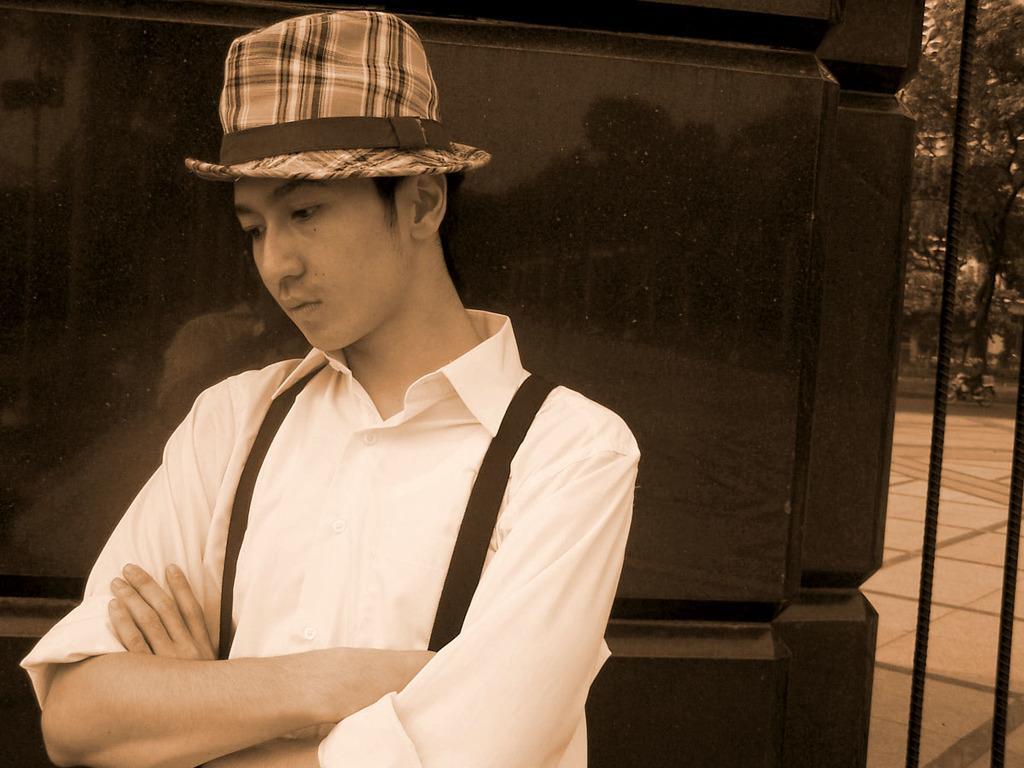Can you describe this image briefly? In this picture I can observe a man. He is wearing shirt and a hat on his head. There is a wall behind him. On the right side there are some trees. This is a black and white image. 